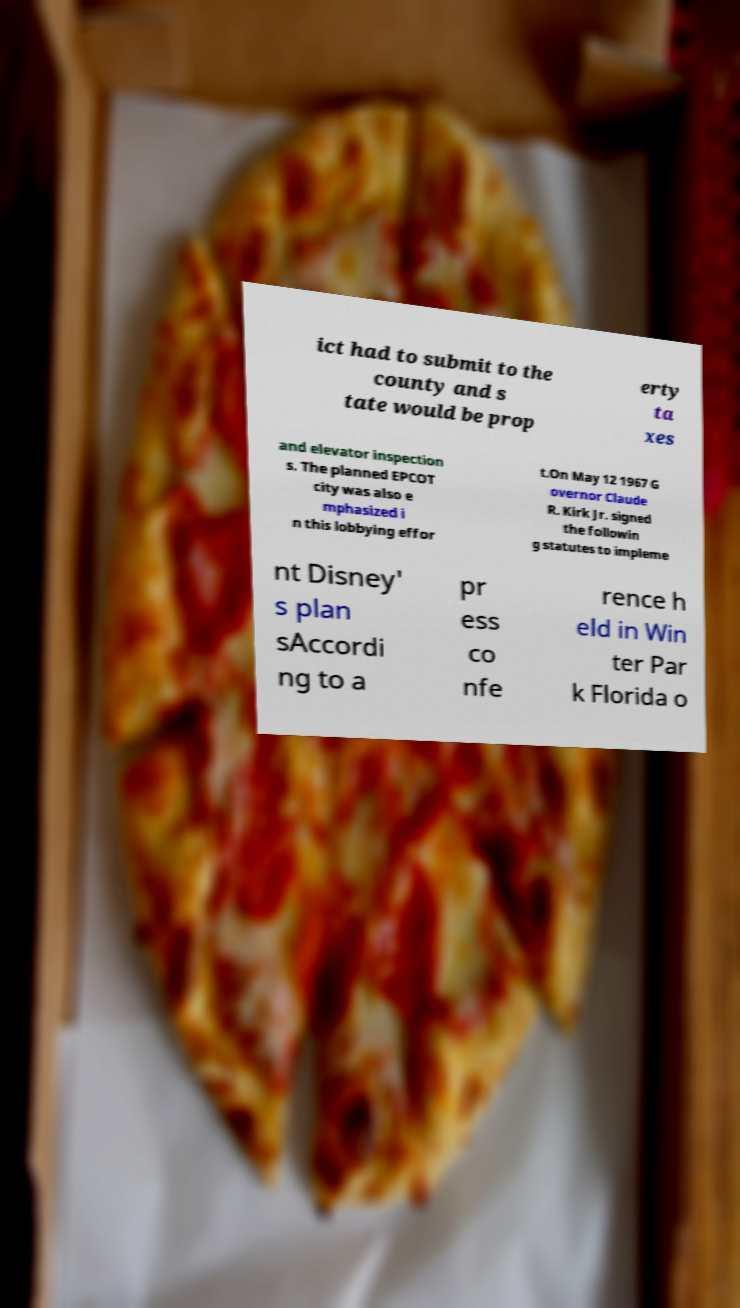Please identify and transcribe the text found in this image. ict had to submit to the county and s tate would be prop erty ta xes and elevator inspection s. The planned EPCOT city was also e mphasized i n this lobbying effor t.On May 12 1967 G overnor Claude R. Kirk Jr. signed the followin g statutes to impleme nt Disney' s plan sAccordi ng to a pr ess co nfe rence h eld in Win ter Par k Florida o 